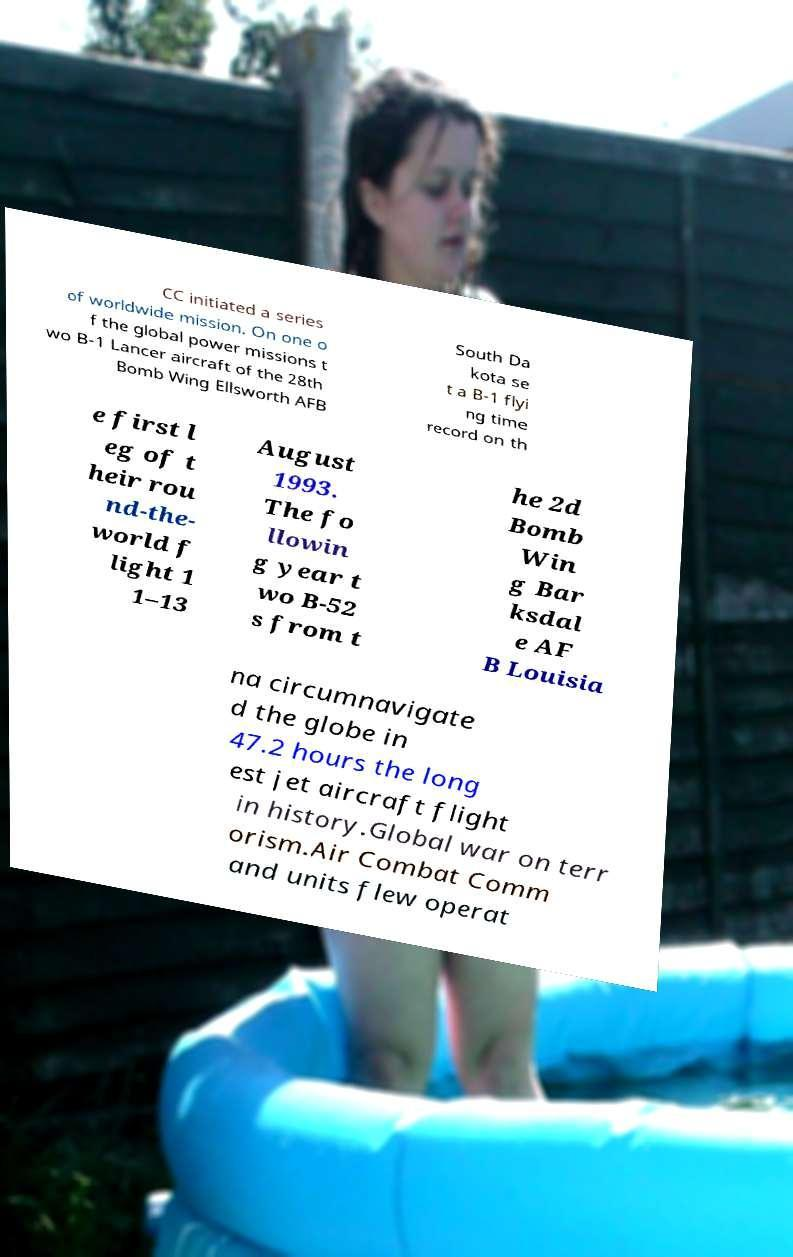Could you assist in decoding the text presented in this image and type it out clearly? CC initiated a series of worldwide mission. On one o f the global power missions t wo B-1 Lancer aircraft of the 28th Bomb Wing Ellsworth AFB South Da kota se t a B-1 flyi ng time record on th e first l eg of t heir rou nd-the- world f light 1 1–13 August 1993. The fo llowin g year t wo B-52 s from t he 2d Bomb Win g Bar ksdal e AF B Louisia na circumnavigate d the globe in 47.2 hours the long est jet aircraft flight in history.Global war on terr orism.Air Combat Comm and units flew operat 